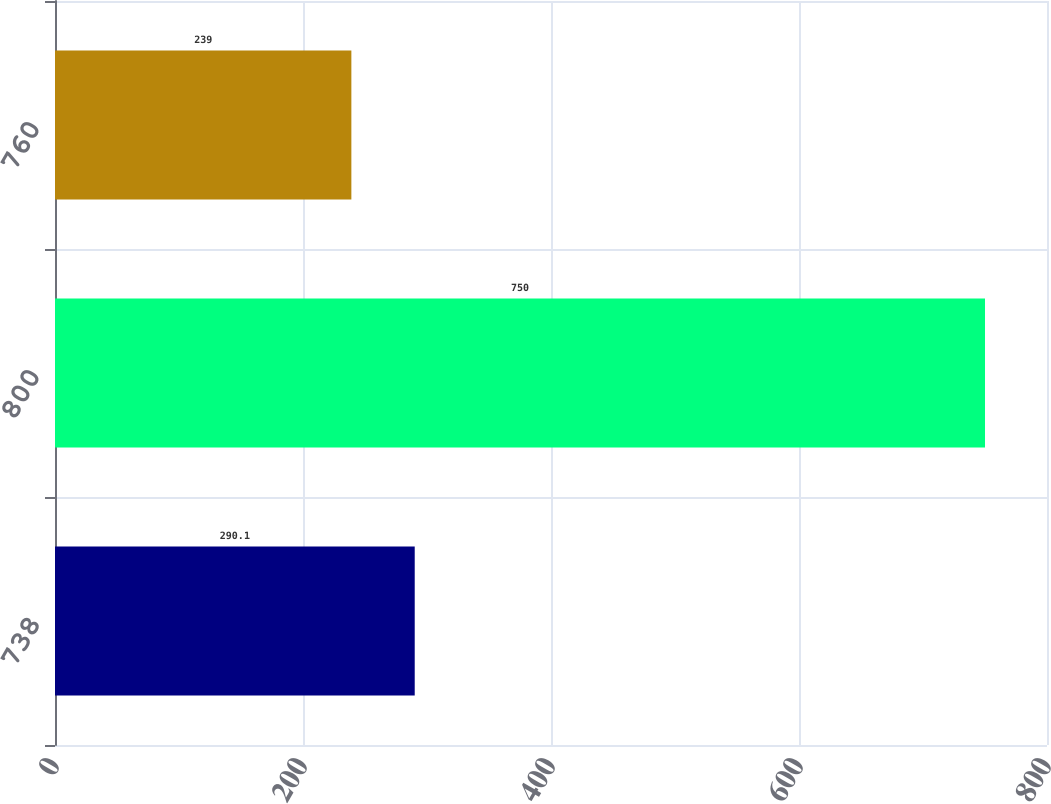<chart> <loc_0><loc_0><loc_500><loc_500><bar_chart><fcel>738<fcel>800<fcel>760<nl><fcel>290.1<fcel>750<fcel>239<nl></chart> 